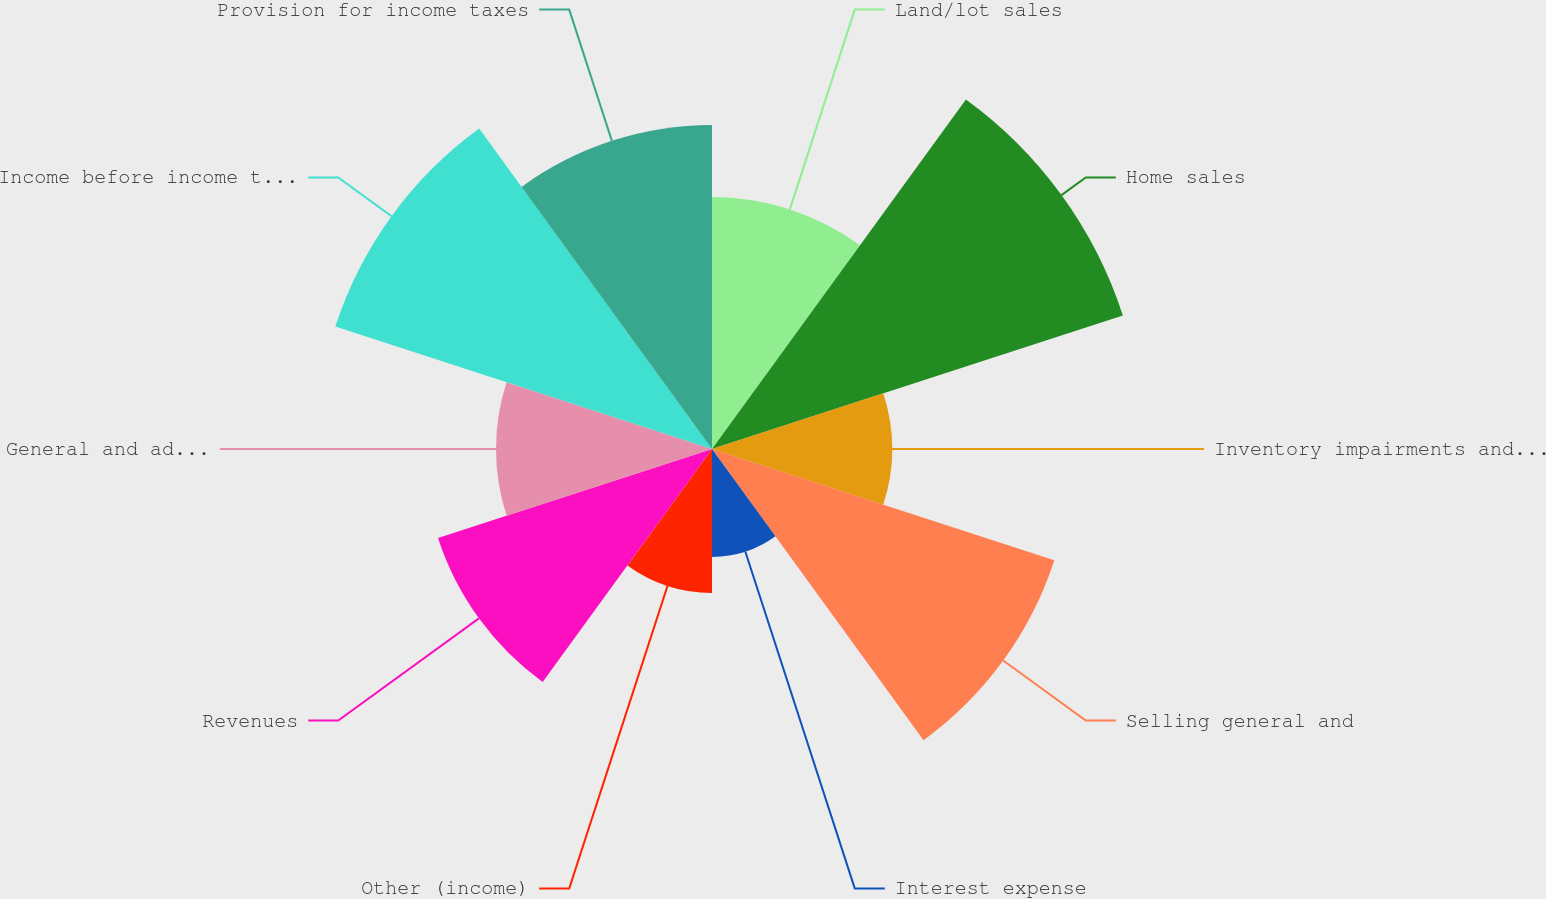Convert chart. <chart><loc_0><loc_0><loc_500><loc_500><pie_chart><fcel>Land/lot sales<fcel>Home sales<fcel>Inventory impairments and land<fcel>Selling general and<fcel>Interest expense<fcel>Other (income)<fcel>Revenues<fcel>General and administrative<fcel>Income before income taxes<fcel>Provision for income taxes<nl><fcel>9.33%<fcel>16.0%<fcel>6.67%<fcel>13.33%<fcel>4.0%<fcel>5.33%<fcel>10.67%<fcel>8.0%<fcel>14.67%<fcel>12.0%<nl></chart> 